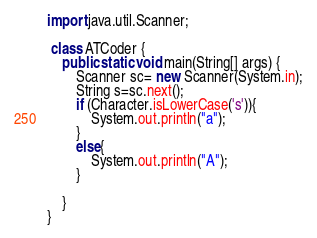Convert code to text. <code><loc_0><loc_0><loc_500><loc_500><_Java_>import java.util.Scanner;

 class ATCoder {
    public static void main(String[] args) {
        Scanner sc= new Scanner(System.in);
        String s=sc.next();
        if (Character.isLowerCase('s')){
            System.out.println("a");
        }
        else{
            System.out.println("A");
        }

    }
}
</code> 